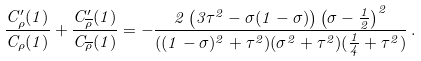<formula> <loc_0><loc_0><loc_500><loc_500>\frac { C ^ { \prime } _ { \rho } ( 1 ) } { C _ { \rho } ( 1 ) } + \frac { C ^ { \prime } _ { \overline { \rho } } ( 1 ) } { C _ { \overline { \rho } } ( 1 ) } = - \frac { 2 \left ( 3 \tau ^ { 2 } - \sigma ( 1 - \sigma ) \right ) \left ( \sigma - \frac { 1 } { 2 } \right ) ^ { 2 } } { ( ( 1 - \sigma ) ^ { 2 } + \tau ^ { 2 } ) ( \sigma ^ { 2 } + \tau ^ { 2 } ) ( \frac { 1 } { 4 } + \tau ^ { 2 } ) } \, .</formula> 